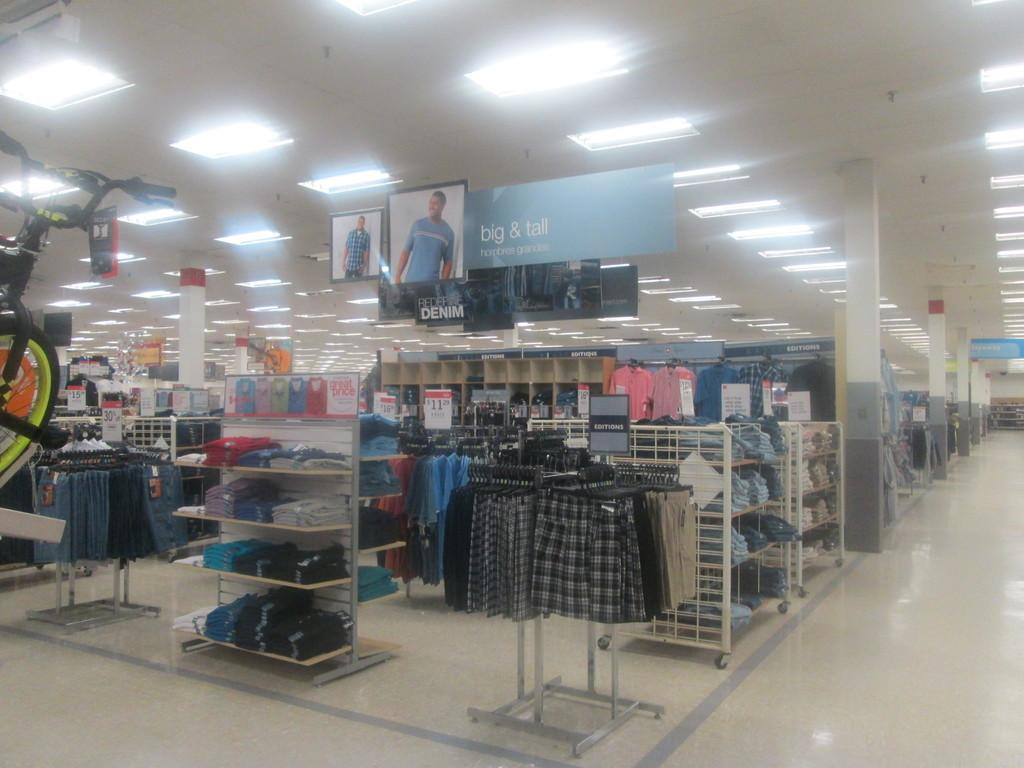<image>
Give a short and clear explanation of the subsequent image. Department store clothing isles featuring a sign for the big & tall men's department. 